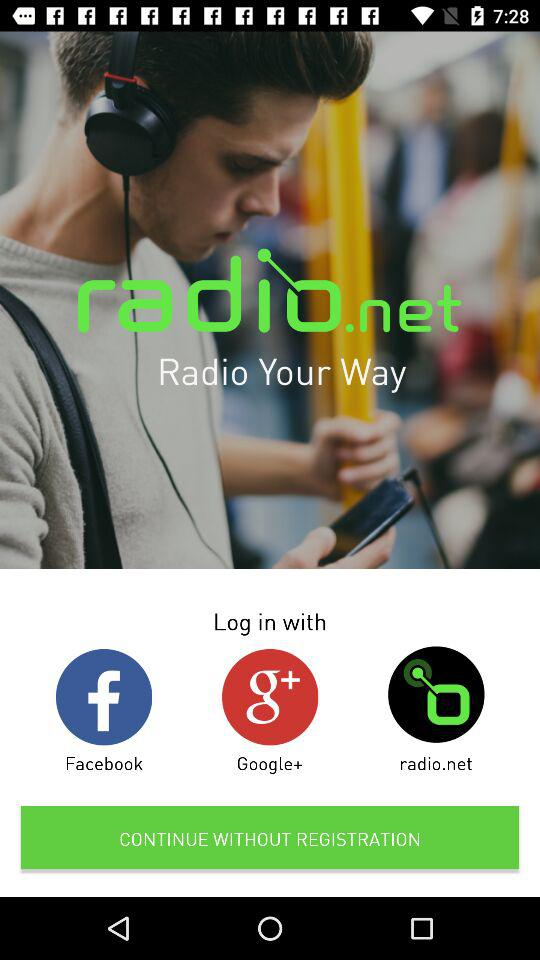What is the application name? The application name is "radio.net Radio Your Way". 